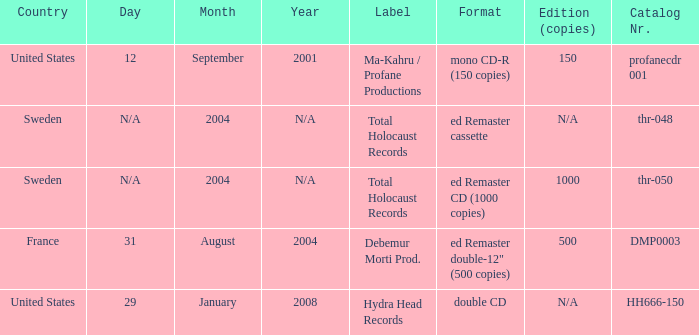Could you help me parse every detail presented in this table? {'header': ['Country', 'Day', 'Month', 'Year', 'Label', 'Format', 'Edition (copies)', 'Catalog Nr.'], 'rows': [['United States', '12', 'September', '2001', 'Ma-Kahru / Profane Productions', 'mono CD-R (150 copies)', '150', 'profanecdr 001'], ['Sweden', 'N/A', '2004', 'N/A', 'Total Holocaust Records', 'ed Remaster cassette', 'N/A', 'thr-048'], ['Sweden', 'N/A', '2004', 'N/A', 'Total Holocaust Records', 'ed Remaster CD (1000 copies)', '1000', 'thr-050'], ['France', '31', 'August', '2004', 'Debemur Morti Prod.', 'ed Remaster double-12" (500 copies)', '500', 'DMP0003'], ['United States', '29', 'January', '2008', 'Hydra Head Records', 'double CD', 'N/A', 'HH666-150']]} What country is the Debemur Morti prod. label from? France. 